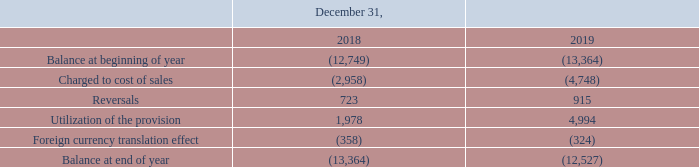NOTE 8. INVENTORIES
The changes in the allowance for obsolescence are as follows:
On December 31, 2019, our allowance for inventory obsolescence amounted to €12,527, which is 6.7% of total inventory. The major part of the allowance is related to components and raw materials. The additions for the years 2018 and 2019 mainly relate to inventory items which ceased to be used due to technological developments and design changes which resulted in obsolescence of certain parts.
The cost of inventories recognized as costs and included in cost of sales amounted to €510.2 million (2018: €365.8 million).
What does the table show? Changes in the allowance for obsolescence. What is the major part of the obsolescence allowance? Components and raw materials. What was the Balance at beginning of year 2019? (13,364). What is the percentage change in Balance at end of year from 2018 to 2019?
Answer scale should be: percent. ( -12,527 - (-13,364))/-13,364
Answer: -6.26. Which component caused the greatest increase in allowance for inventory obsolescence in 2019? Find the largest negative number in COL4 ROWS 4 to 7
Answer: charged to cost of sales. What is the change in reversals from 2018 to 2019? 915-723
Answer: 192. 